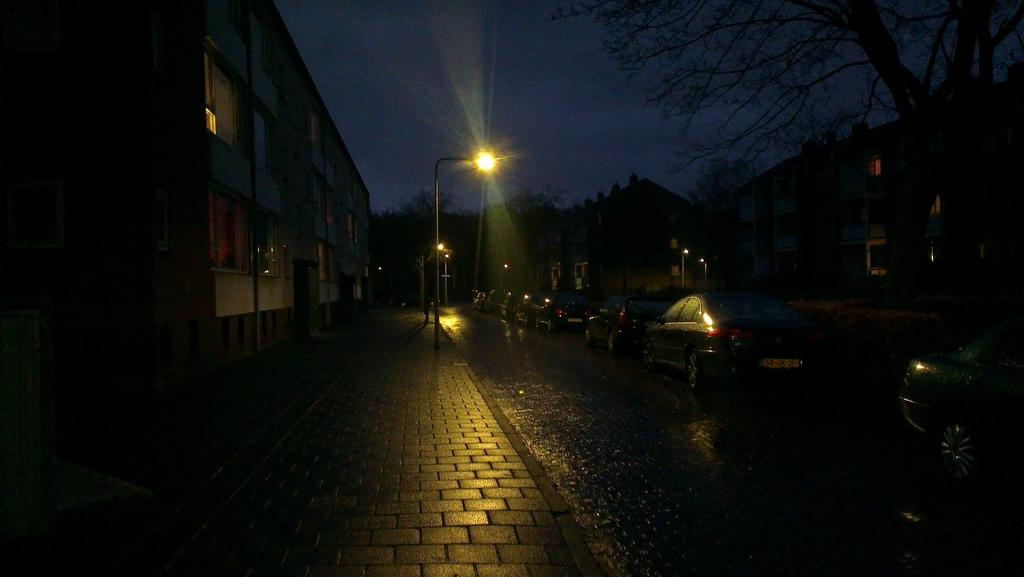What can be seen on the roads in the image? There are many cars on the roads in the image. What type of infrastructure is present along the roads? Street lights are visible in the image. What can be seen in the background of the image? There are trees and buildings in the background of the image. What is visible at the top of the image? The sky is visible at the top of the image. What type of paper is being used to cover the lamps in the image? There are no lamps or paper present in the image; it features cars on the roads, street lights, trees, buildings, and the sky. 